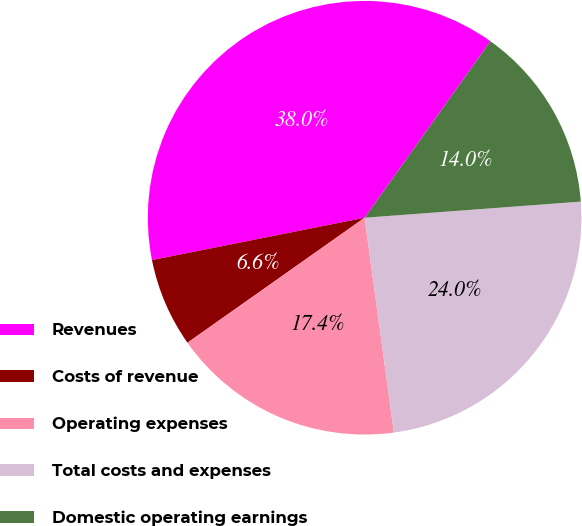<chart> <loc_0><loc_0><loc_500><loc_500><pie_chart><fcel>Revenues<fcel>Costs of revenue<fcel>Operating expenses<fcel>Total costs and expenses<fcel>Domestic operating earnings<nl><fcel>37.99%<fcel>6.65%<fcel>17.38%<fcel>24.03%<fcel>13.96%<nl></chart> 